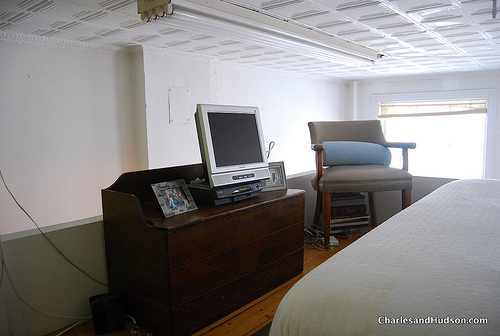Is the window below the blinds? Yes, the window is indeed situated below the blinds, as seen in the image. 